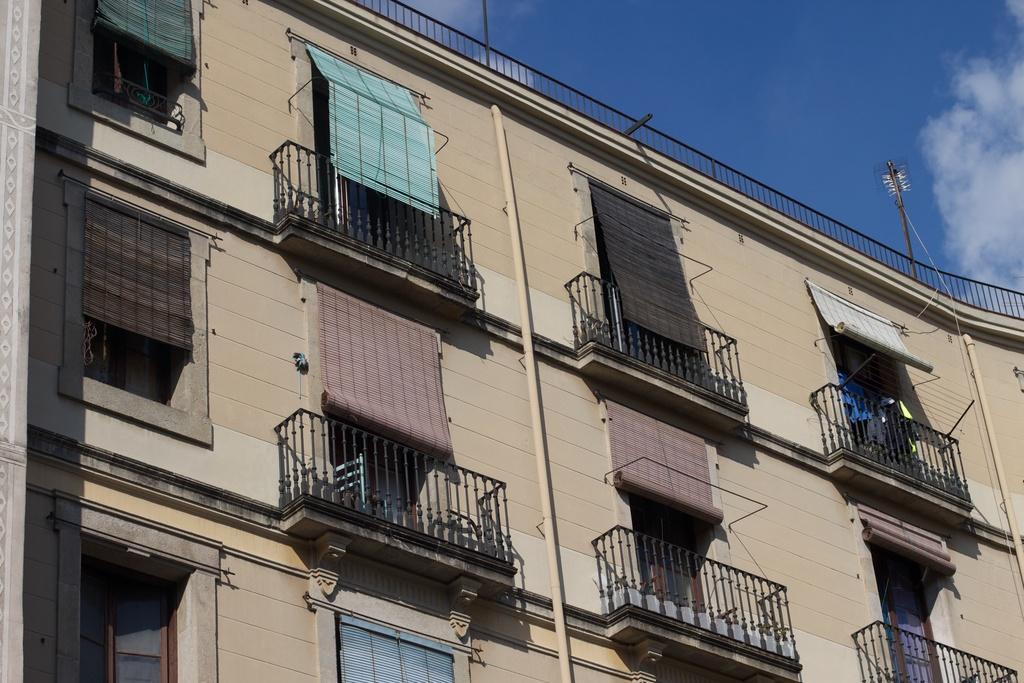In one or two sentences, can you explain what this image depicts? This is a picture of a building. in this picture there are windows, window blinds, railing, pipes, poles and wall. Sky is clear and it is sunny. 